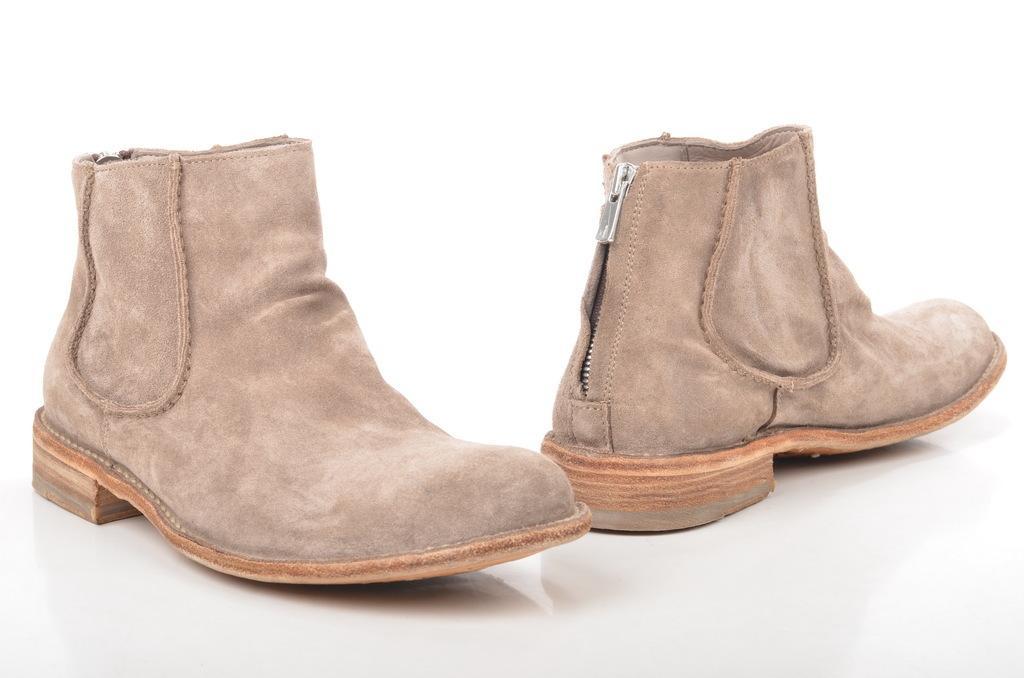Can you describe this image briefly? On the left side, there is a brown color shoe on a surface. On the right side, there is another shoe on the surface. And the background is white in color. 